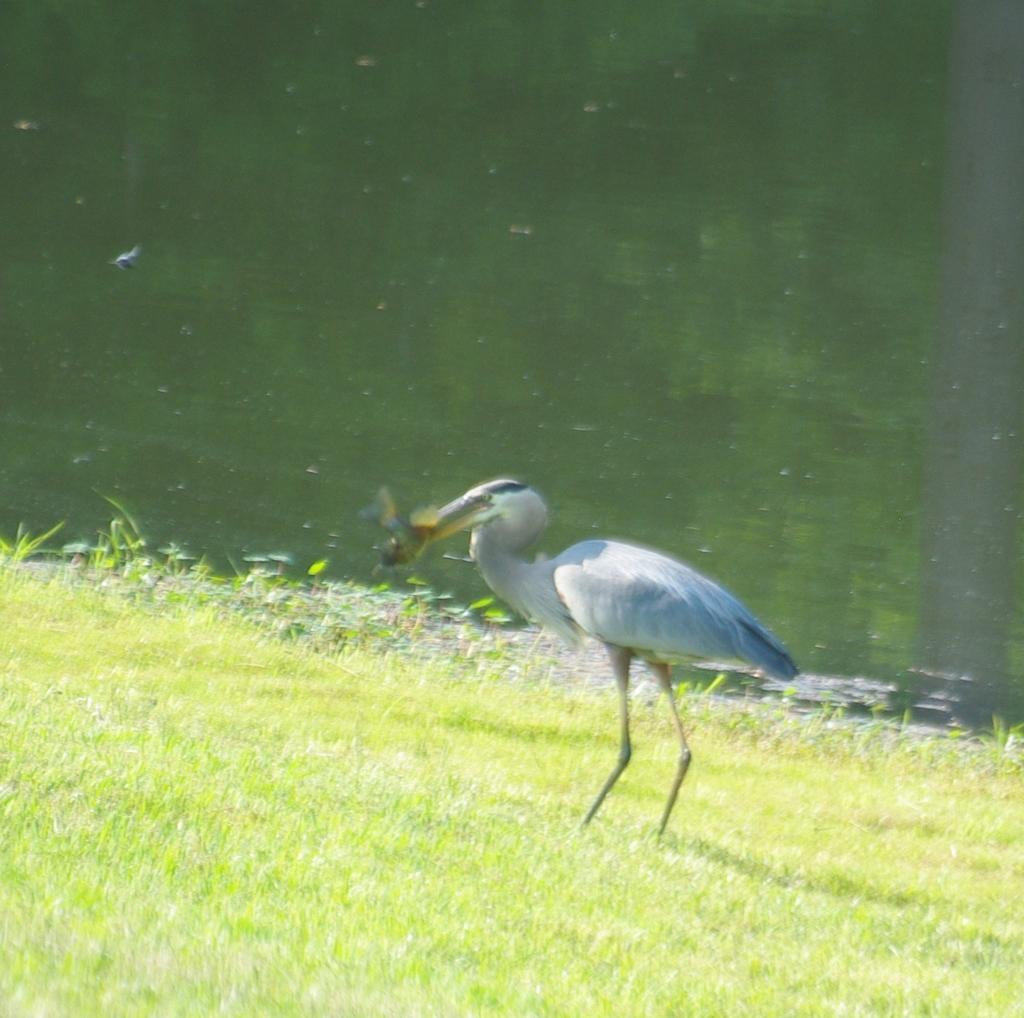What type of animal is in the image? There is a bird in the image. What colors can be seen on the bird? The bird has white and blue colors. What natural element is visible in the image? There is water visible in the image. What type of vegetation is present in the image? There is green grass in the image. What type of lumber is being used to build a structure in the image? There is no lumber or structure being built in the image; it features a bird, water, and green grass. Can you see any steam coming from the bird in the image? No, there is no steam present in the image. 